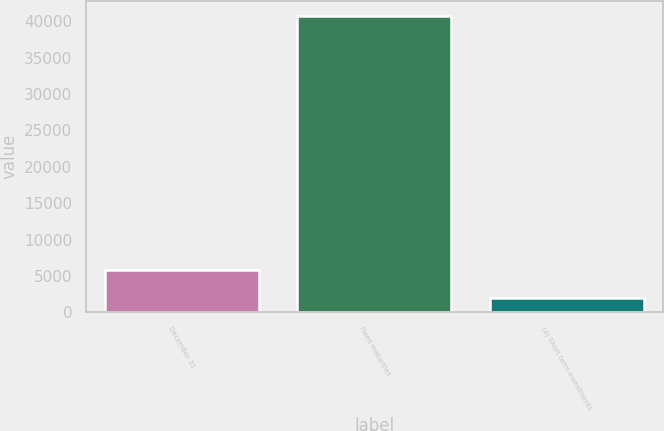Convert chart. <chart><loc_0><loc_0><loc_500><loc_500><bar_chart><fcel>December 31<fcel>Fixed maturities<fcel>(a) Short term investments<nl><fcel>5875.6<fcel>40765<fcel>1999<nl></chart> 